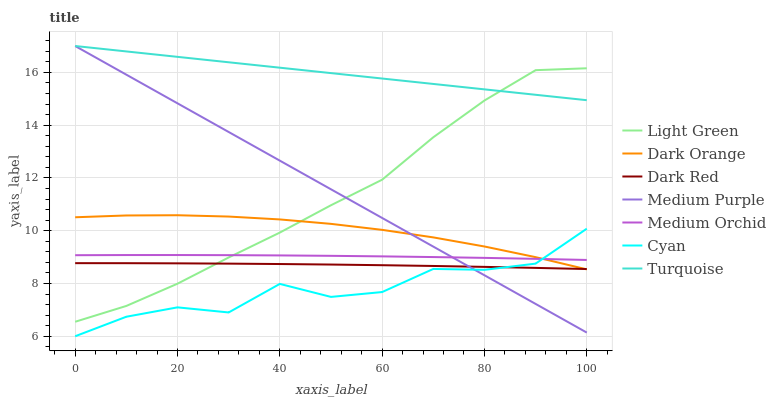Does Cyan have the minimum area under the curve?
Answer yes or no. Yes. Does Turquoise have the maximum area under the curve?
Answer yes or no. Yes. Does Dark Red have the minimum area under the curve?
Answer yes or no. No. Does Dark Red have the maximum area under the curve?
Answer yes or no. No. Is Medium Purple the smoothest?
Answer yes or no. Yes. Is Cyan the roughest?
Answer yes or no. Yes. Is Turquoise the smoothest?
Answer yes or no. No. Is Turquoise the roughest?
Answer yes or no. No. Does Dark Red have the lowest value?
Answer yes or no. No. Does Dark Red have the highest value?
Answer yes or no. No. Is Cyan less than Light Green?
Answer yes or no. Yes. Is Turquoise greater than Medium Orchid?
Answer yes or no. Yes. Does Cyan intersect Light Green?
Answer yes or no. No. 